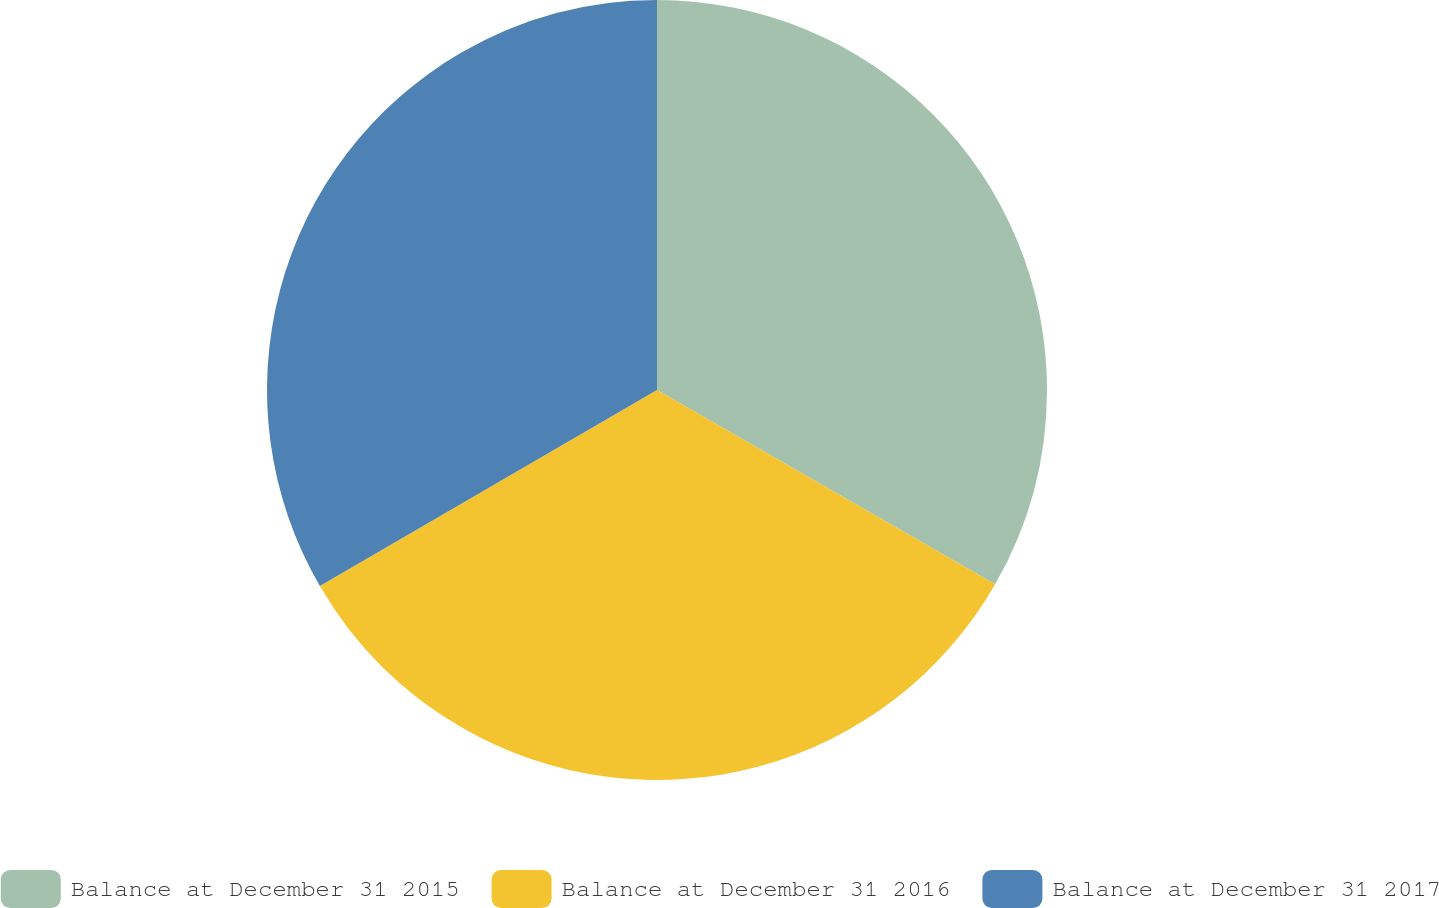<chart> <loc_0><loc_0><loc_500><loc_500><pie_chart><fcel>Balance at December 31 2015<fcel>Balance at December 31 2016<fcel>Balance at December 31 2017<nl><fcel>33.3%<fcel>33.31%<fcel>33.38%<nl></chart> 